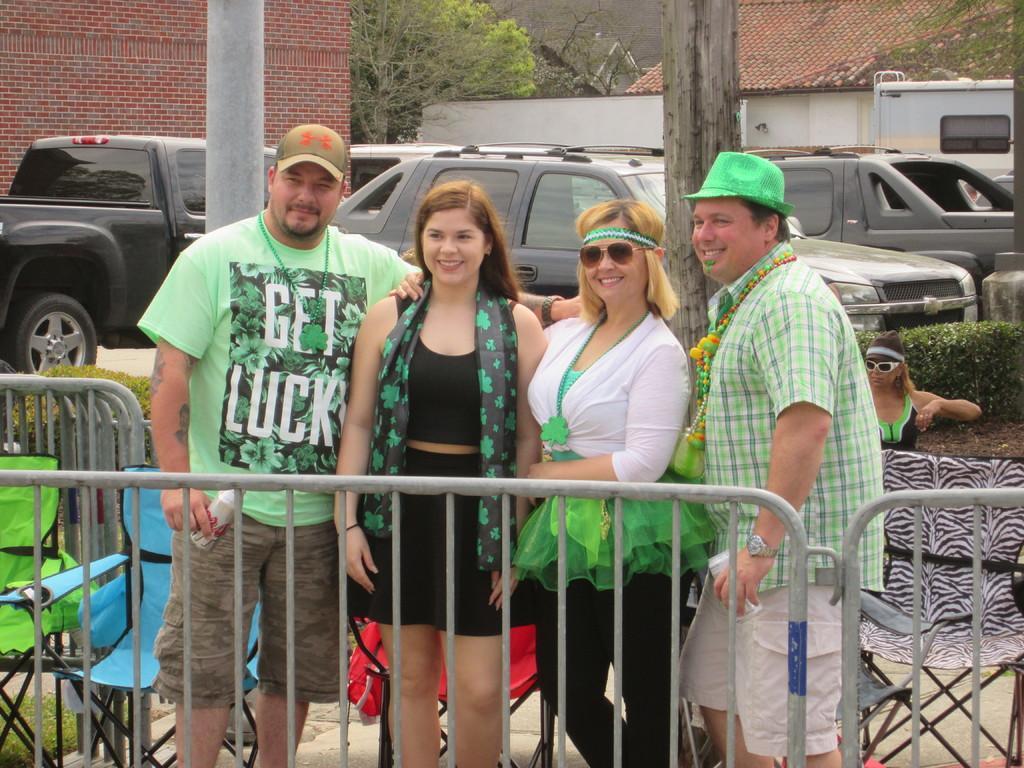Please provide a concise description of this image. In this picture there are group of people standing behind the railing and smiling. At the back there are vehicles, buildings, trees and chairs. There is a person standing behind the chair. At the bottom there is grass. 